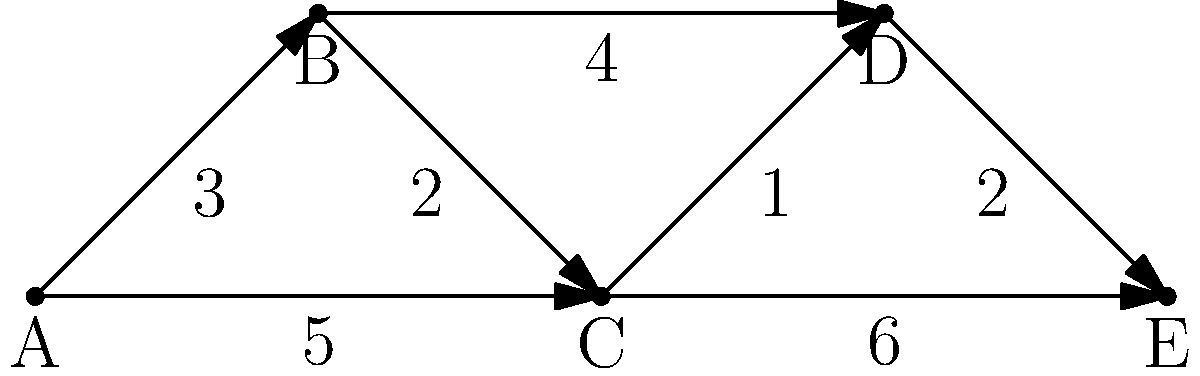In the given neuronal network diagram, each node represents a neuron and each edge represents a synaptic connection with its associated transmission time (in milliseconds). What is the shortest time (in milliseconds) for a signal to propagate from neuron A to neuron E? To find the shortest path from neuron A to neuron E, we'll use Dijkstra's algorithm:

1. Initialize:
   - Set distance to A as 0, all others as infinity.
   - Set all nodes as unvisited.

2. For the current node (starting with A), consider all unvisited neighbors and calculate their tentative distances.
   - A to B: 3 ms
   - A to C: 5 ms

3. Mark A as visited. B has the smallest tentative distance, so it becomes the current node.

4. Update distances from B:
   - B to C: 3 + 2 = 5 ms (no change)
   - B to D: 3 + 4 = 7 ms

5. Mark B as visited. C has the smallest tentative distance among unvisited nodes.

6. Update distances from C:
   - C to D: 5 + 1 = 6 ms (shorter than current 7 ms)
   - C to E: 5 + 6 = 11 ms

7. Mark C as visited. D is now the current node.

8. Update distance from D:
   - D to E: 6 + 2 = 8 ms (shorter than current 11 ms)

9. Mark D as visited. E is the only unvisited node left.

The shortest path is A → B → C → D → E, with a total time of 8 ms.
Answer: 8 ms 